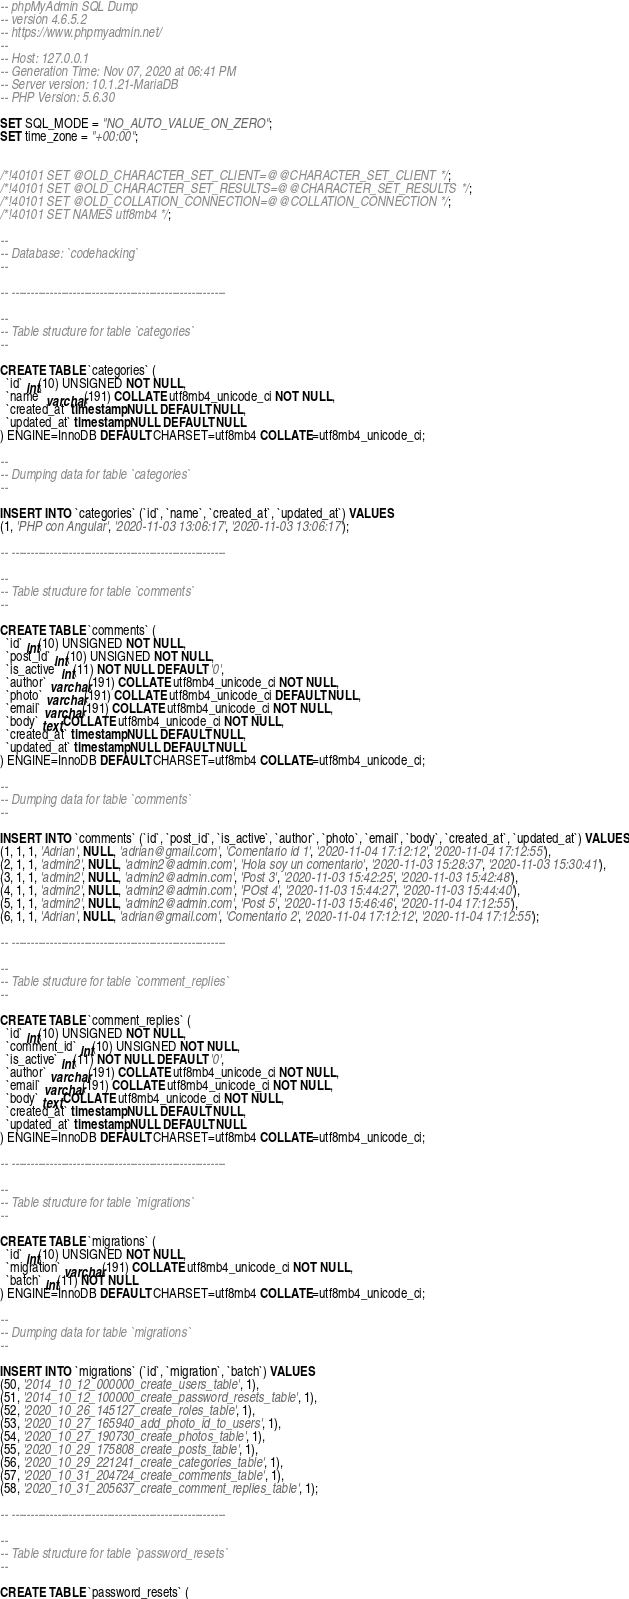<code> <loc_0><loc_0><loc_500><loc_500><_SQL_>-- phpMyAdmin SQL Dump
-- version 4.6.5.2
-- https://www.phpmyadmin.net/
--
-- Host: 127.0.0.1
-- Generation Time: Nov 07, 2020 at 06:41 PM
-- Server version: 10.1.21-MariaDB
-- PHP Version: 5.6.30

SET SQL_MODE = "NO_AUTO_VALUE_ON_ZERO";
SET time_zone = "+00:00";


/*!40101 SET @OLD_CHARACTER_SET_CLIENT=@@CHARACTER_SET_CLIENT */;
/*!40101 SET @OLD_CHARACTER_SET_RESULTS=@@CHARACTER_SET_RESULTS */;
/*!40101 SET @OLD_COLLATION_CONNECTION=@@COLLATION_CONNECTION */;
/*!40101 SET NAMES utf8mb4 */;

--
-- Database: `codehacking`
--

-- --------------------------------------------------------

--
-- Table structure for table `categories`
--

CREATE TABLE `categories` (
  `id` int(10) UNSIGNED NOT NULL,
  `name` varchar(191) COLLATE utf8mb4_unicode_ci NOT NULL,
  `created_at` timestamp NULL DEFAULT NULL,
  `updated_at` timestamp NULL DEFAULT NULL
) ENGINE=InnoDB DEFAULT CHARSET=utf8mb4 COLLATE=utf8mb4_unicode_ci;

--
-- Dumping data for table `categories`
--

INSERT INTO `categories` (`id`, `name`, `created_at`, `updated_at`) VALUES
(1, 'PHP con Angular', '2020-11-03 13:06:17', '2020-11-03 13:06:17');

-- --------------------------------------------------------

--
-- Table structure for table `comments`
--

CREATE TABLE `comments` (
  `id` int(10) UNSIGNED NOT NULL,
  `post_id` int(10) UNSIGNED NOT NULL,
  `is_active` int(11) NOT NULL DEFAULT '0',
  `author` varchar(191) COLLATE utf8mb4_unicode_ci NOT NULL,
  `photo` varchar(191) COLLATE utf8mb4_unicode_ci DEFAULT NULL,
  `email` varchar(191) COLLATE utf8mb4_unicode_ci NOT NULL,
  `body` text COLLATE utf8mb4_unicode_ci NOT NULL,
  `created_at` timestamp NULL DEFAULT NULL,
  `updated_at` timestamp NULL DEFAULT NULL
) ENGINE=InnoDB DEFAULT CHARSET=utf8mb4 COLLATE=utf8mb4_unicode_ci;

--
-- Dumping data for table `comments`
--

INSERT INTO `comments` (`id`, `post_id`, `is_active`, `author`, `photo`, `email`, `body`, `created_at`, `updated_at`) VALUES
(1, 1, 1, 'Adrian', NULL, 'adrian@gmail.com', 'Comentario id 1', '2020-11-04 17:12:12', '2020-11-04 17:12:55'),
(2, 1, 1, 'admin2', NULL, 'admin2@admin.com', 'Hola soy un comentario', '2020-11-03 15:28:37', '2020-11-03 15:30:41'),
(3, 1, 1, 'admin2', NULL, 'admin2@admin.com', 'Post 3', '2020-11-03 15:42:25', '2020-11-03 15:42:48'),
(4, 1, 1, 'admin2', NULL, 'admin2@admin.com', 'POst 4', '2020-11-03 15:44:27', '2020-11-03 15:44:40'),
(5, 1, 1, 'admin2', NULL, 'admin2@admin.com', 'Post 5', '2020-11-03 15:46:46', '2020-11-04 17:12:55'),
(6, 1, 1, 'Adrian', NULL, 'adrian@gmail.com', 'Comentario 2', '2020-11-04 17:12:12', '2020-11-04 17:12:55');

-- --------------------------------------------------------

--
-- Table structure for table `comment_replies`
--

CREATE TABLE `comment_replies` (
  `id` int(10) UNSIGNED NOT NULL,
  `comment_id` int(10) UNSIGNED NOT NULL,
  `is_active` int(11) NOT NULL DEFAULT '0',
  `author` varchar(191) COLLATE utf8mb4_unicode_ci NOT NULL,
  `email` varchar(191) COLLATE utf8mb4_unicode_ci NOT NULL,
  `body` text COLLATE utf8mb4_unicode_ci NOT NULL,
  `created_at` timestamp NULL DEFAULT NULL,
  `updated_at` timestamp NULL DEFAULT NULL
) ENGINE=InnoDB DEFAULT CHARSET=utf8mb4 COLLATE=utf8mb4_unicode_ci;

-- --------------------------------------------------------

--
-- Table structure for table `migrations`
--

CREATE TABLE `migrations` (
  `id` int(10) UNSIGNED NOT NULL,
  `migration` varchar(191) COLLATE utf8mb4_unicode_ci NOT NULL,
  `batch` int(11) NOT NULL
) ENGINE=InnoDB DEFAULT CHARSET=utf8mb4 COLLATE=utf8mb4_unicode_ci;

--
-- Dumping data for table `migrations`
--

INSERT INTO `migrations` (`id`, `migration`, `batch`) VALUES
(50, '2014_10_12_000000_create_users_table', 1),
(51, '2014_10_12_100000_create_password_resets_table', 1),
(52, '2020_10_26_145127_create_roles_table', 1),
(53, '2020_10_27_165940_add_photo_id_to_users', 1),
(54, '2020_10_27_190730_create_photos_table', 1),
(55, '2020_10_29_175808_create_posts_table', 1),
(56, '2020_10_29_221241_create_categories_table', 1),
(57, '2020_10_31_204724_create_comments_table', 1),
(58, '2020_10_31_205637_create_comment_replies_table', 1);

-- --------------------------------------------------------

--
-- Table structure for table `password_resets`
--

CREATE TABLE `password_resets` (</code> 